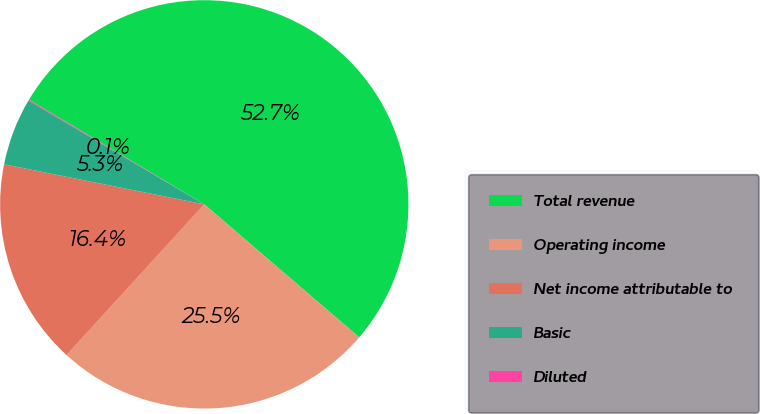Convert chart. <chart><loc_0><loc_0><loc_500><loc_500><pie_chart><fcel>Total revenue<fcel>Operating income<fcel>Net income attributable to<fcel>Basic<fcel>Diluted<nl><fcel>52.72%<fcel>25.49%<fcel>16.36%<fcel>5.35%<fcel>0.08%<nl></chart> 